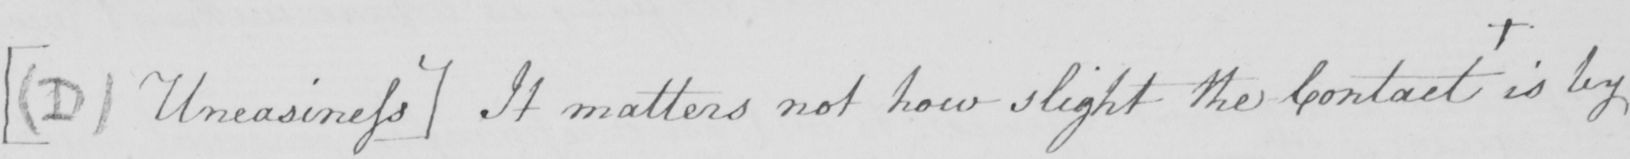Transcribe the text shown in this historical manuscript line. [(D) Uneasiness] It matters not how slight the contact + is by 